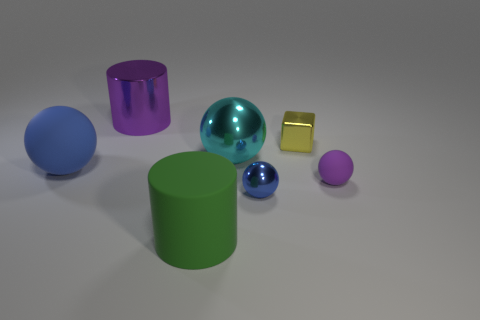Are there fewer large green matte cylinders that are right of the big cyan metallic ball than big metallic cylinders on the left side of the metallic cylinder?
Offer a very short reply. No. Is the color of the large cylinder that is in front of the purple matte sphere the same as the metal object that is left of the cyan metal thing?
Provide a succinct answer. No. Is there a small blue ball that has the same material as the purple sphere?
Your answer should be compact. No. What is the size of the sphere that is right of the blue ball that is in front of the purple sphere?
Your answer should be compact. Small. Is the number of big cyan things greater than the number of big brown balls?
Your answer should be very brief. Yes. There is a blue thing left of the cyan metal thing; does it have the same size as the green cylinder?
Your answer should be very brief. Yes. What number of rubber balls are the same color as the matte cylinder?
Your answer should be compact. 0. Do the green rubber object and the large purple object have the same shape?
Offer a terse response. Yes. What is the size of the other rubber object that is the same shape as the blue matte thing?
Offer a terse response. Small. Are there more rubber objects on the left side of the small yellow metal object than large cyan shiny things that are in front of the green rubber thing?
Your answer should be very brief. Yes. 